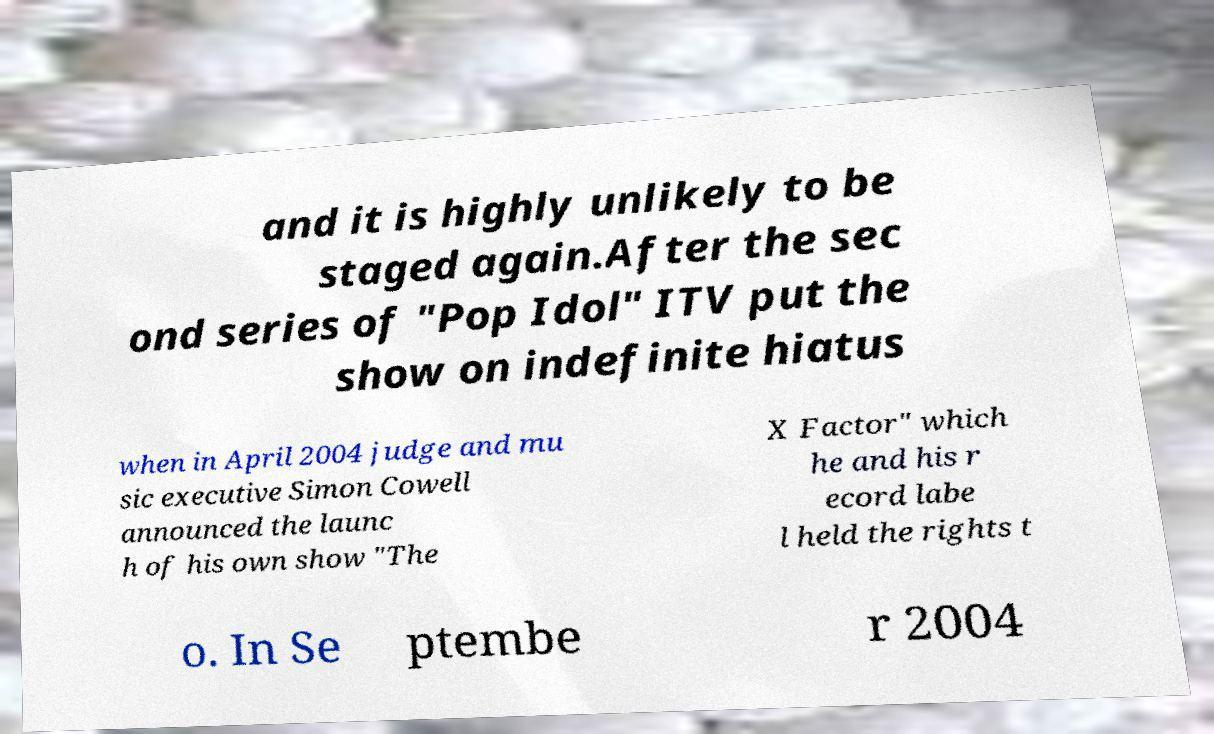Please identify and transcribe the text found in this image. and it is highly unlikely to be staged again.After the sec ond series of "Pop Idol" ITV put the show on indefinite hiatus when in April 2004 judge and mu sic executive Simon Cowell announced the launc h of his own show "The X Factor" which he and his r ecord labe l held the rights t o. In Se ptembe r 2004 